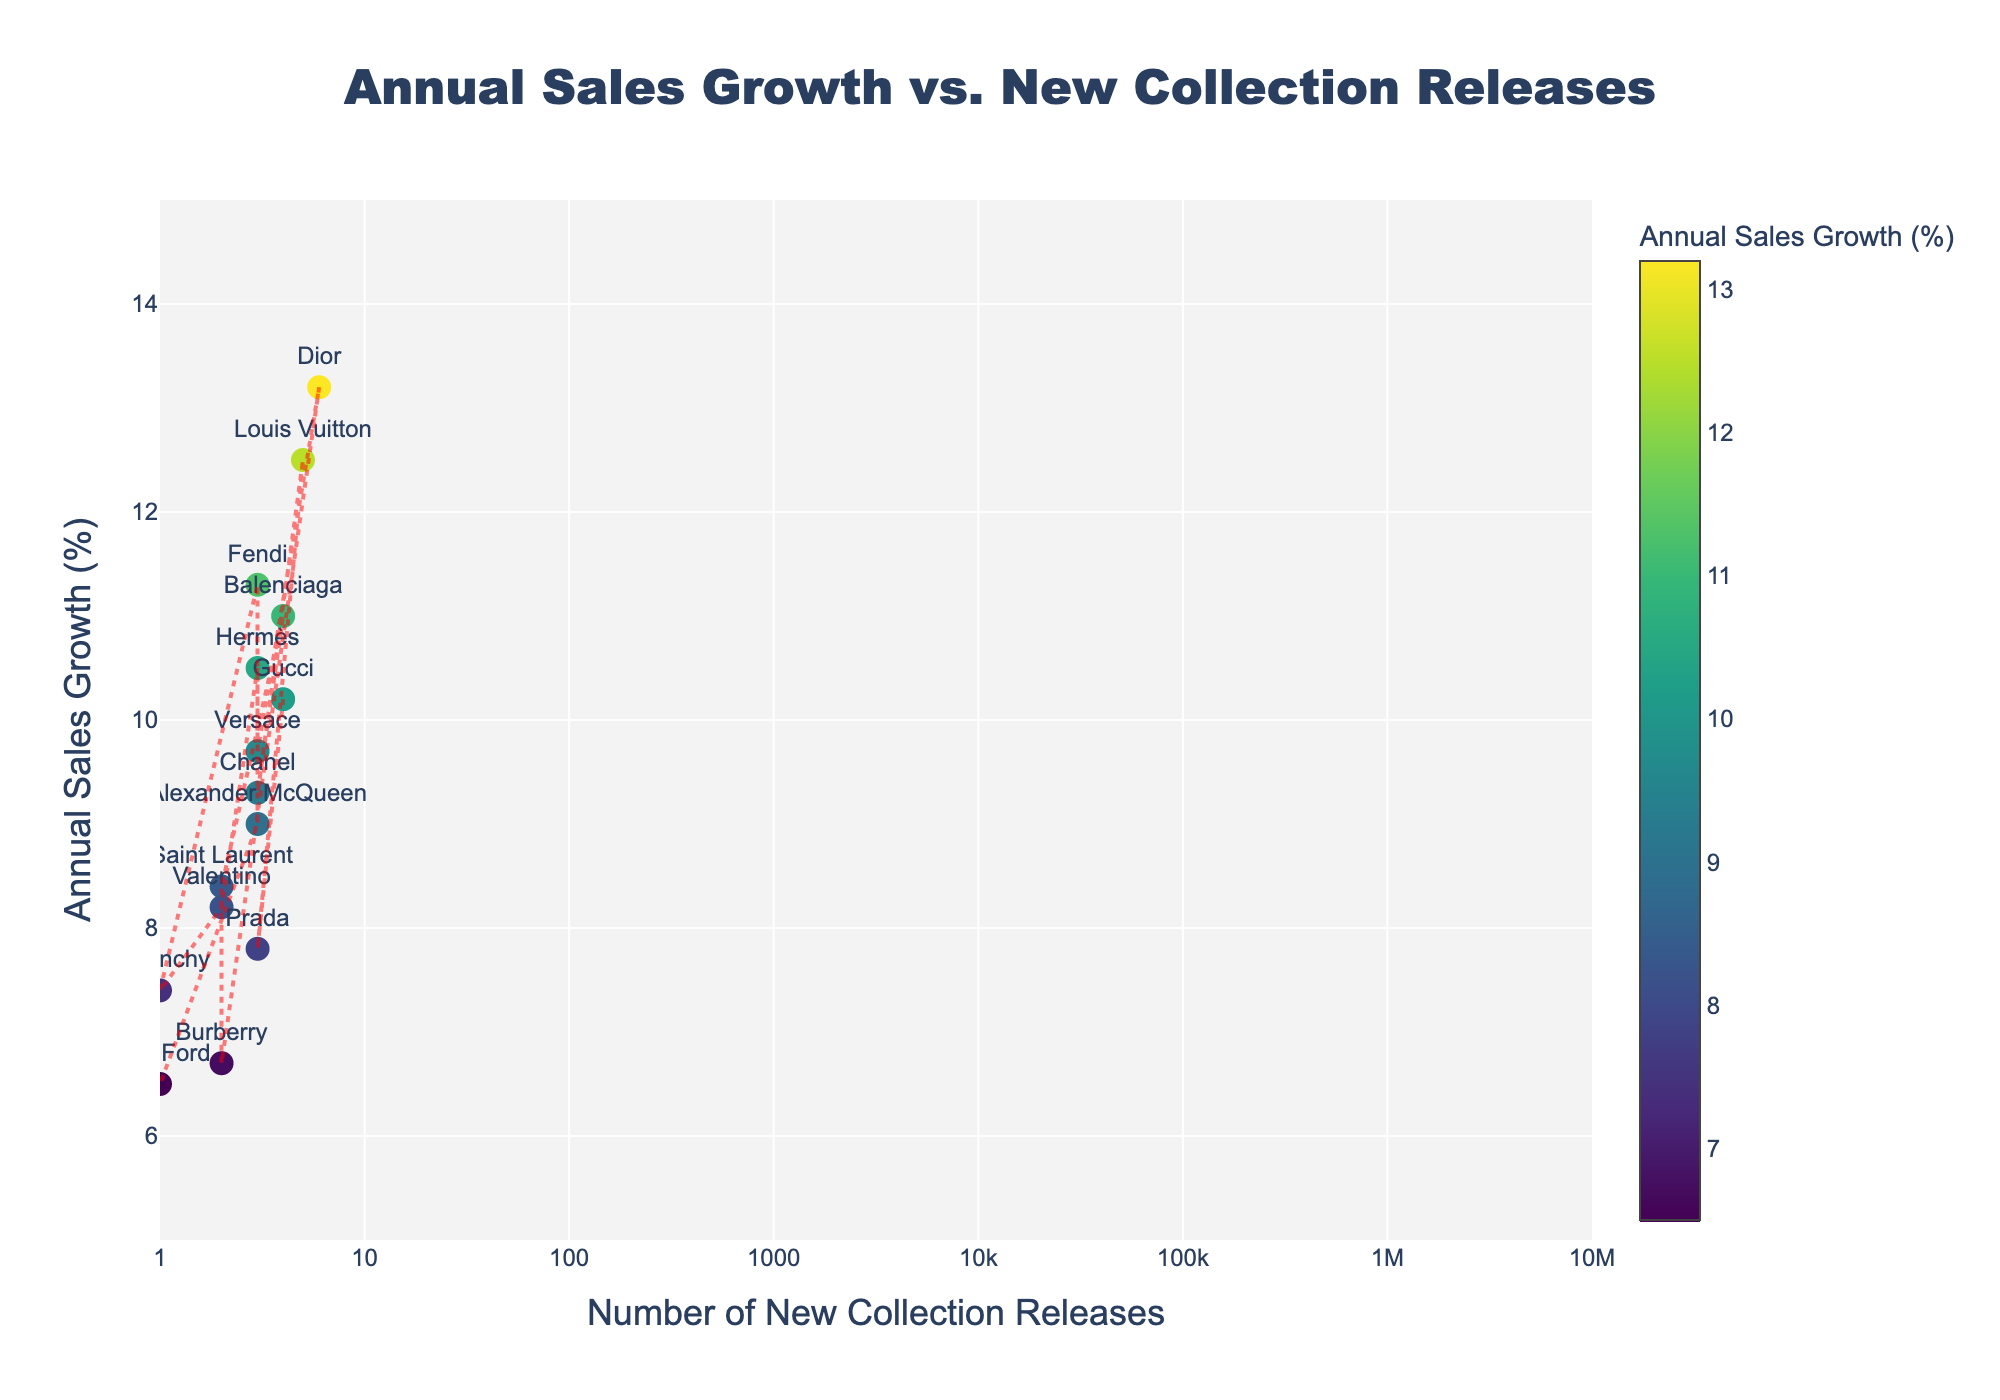What is the brand with the highest annual sales growth? The brand with the highest annual sales growth can be identified by locating the highest point on the y-axis (Annual Sales Growth %). Hovering over the data points reveals that Dior has the highest annual sales growth at 13.2%.
Answer: Dior How many new collection releases does Gucci have? To find the number of new collection releases for Gucci, locate the point labeled "Gucci" on the plot and check the x-axis value, which represents the number of new collection releases. Gucci has 4 new collection releases.
Answer: 4 What is the range of annual sales growth percentages represented in the figure? The range of annual sales growth percentages can be determined by looking at the y-axis, which spans from the lowest value (6.5%) to the highest value (13.2%) in the plot.
Answer: 6.5% to 13.2% Are there any brands with exactly 2 new collection releases? If so, name them and their annual sales growth percentages. To find brands with exactly 2 new collection releases, identify points on the plot where the x-value equals 2. Saint Laurent (8.4%), Burberry (6.7%), and Valentino (8.2%) have exactly 2 new collection releases.
Answer: Saint Laurent (8.4%), Burberry (6.7%), Valentino (8.2%) Which brand has a higher annual sales growth, Chanel or Versace? Compare the y-axis values of the points labeled "Chanel" and "Versace" to determine which has a higher annual sales growth. Chanel has 9.3% and Versace has 9.7%. Versace has a higher annual sales growth.
Answer: Versace Is there a noticeable trend between the number of new collection releases and annual sales growth? Look at the trend line added to the plot. If the trend line shows a general direction (upward or downward), it indicates a trend. The line appears to show a rising trend, suggesting a positive relationship between the number of new collection releases and annual sales growth.
Answer: Yes, positive trend What is the average annual sales growth for brands with 3 new collection releases? Identify the points where the x-value is 3 and calculate their average y-value (annual sales growth). The brands are Prada (7.8%), Chanel (9.3%), Versace (9.7%), Hermès (10.5%), Fendi (11.3%), Alexander McQueen (9.0%). Average = (7.8 + 9.3 + 9.7 + 10.5 + 11.3 + 9.0) / 6 = 9.6%
Answer: 9.6% Are there any outliers in annual sales growth compared to the number of new collection releases? Identify points that are much higher or lower than the general trend line. Dior at 13.2% with 6 new collections stands out as an outlier with the highest annual sales growth.
Answer: Yes, Dior What is the median number of new collection releases among the brands? Arrange the number of new collection releases in ascending order: 1, 1, 2, 2, 2, 3, 3, 3, 3, 3, 3, 4, 4, 5, 6. Since there are 15 values, the median is the 8th value (3).
Answer: 3 Which brand(s) release the least number of new collections and what is their corresponding annual sales growth? Identify the point(s) with the lowest x-value (1). Givenchy (7.4%) and Tom Ford (6.5%) have the least number of new collections (1 each).
Answer: Givenchy (7.4%), Tom Ford (6.5%) 